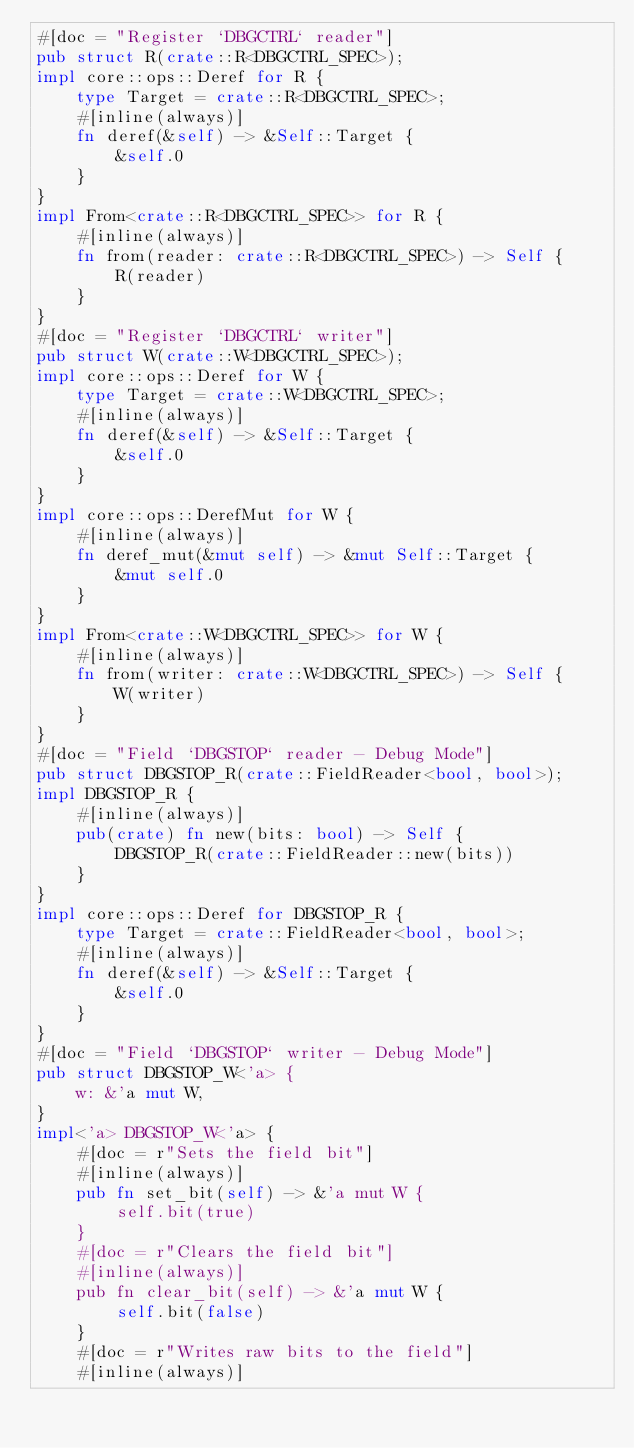Convert code to text. <code><loc_0><loc_0><loc_500><loc_500><_Rust_>#[doc = "Register `DBGCTRL` reader"]
pub struct R(crate::R<DBGCTRL_SPEC>);
impl core::ops::Deref for R {
    type Target = crate::R<DBGCTRL_SPEC>;
    #[inline(always)]
    fn deref(&self) -> &Self::Target {
        &self.0
    }
}
impl From<crate::R<DBGCTRL_SPEC>> for R {
    #[inline(always)]
    fn from(reader: crate::R<DBGCTRL_SPEC>) -> Self {
        R(reader)
    }
}
#[doc = "Register `DBGCTRL` writer"]
pub struct W(crate::W<DBGCTRL_SPEC>);
impl core::ops::Deref for W {
    type Target = crate::W<DBGCTRL_SPEC>;
    #[inline(always)]
    fn deref(&self) -> &Self::Target {
        &self.0
    }
}
impl core::ops::DerefMut for W {
    #[inline(always)]
    fn deref_mut(&mut self) -> &mut Self::Target {
        &mut self.0
    }
}
impl From<crate::W<DBGCTRL_SPEC>> for W {
    #[inline(always)]
    fn from(writer: crate::W<DBGCTRL_SPEC>) -> Self {
        W(writer)
    }
}
#[doc = "Field `DBGSTOP` reader - Debug Mode"]
pub struct DBGSTOP_R(crate::FieldReader<bool, bool>);
impl DBGSTOP_R {
    #[inline(always)]
    pub(crate) fn new(bits: bool) -> Self {
        DBGSTOP_R(crate::FieldReader::new(bits))
    }
}
impl core::ops::Deref for DBGSTOP_R {
    type Target = crate::FieldReader<bool, bool>;
    #[inline(always)]
    fn deref(&self) -> &Self::Target {
        &self.0
    }
}
#[doc = "Field `DBGSTOP` writer - Debug Mode"]
pub struct DBGSTOP_W<'a> {
    w: &'a mut W,
}
impl<'a> DBGSTOP_W<'a> {
    #[doc = r"Sets the field bit"]
    #[inline(always)]
    pub fn set_bit(self) -> &'a mut W {
        self.bit(true)
    }
    #[doc = r"Clears the field bit"]
    #[inline(always)]
    pub fn clear_bit(self) -> &'a mut W {
        self.bit(false)
    }
    #[doc = r"Writes raw bits to the field"]
    #[inline(always)]</code> 